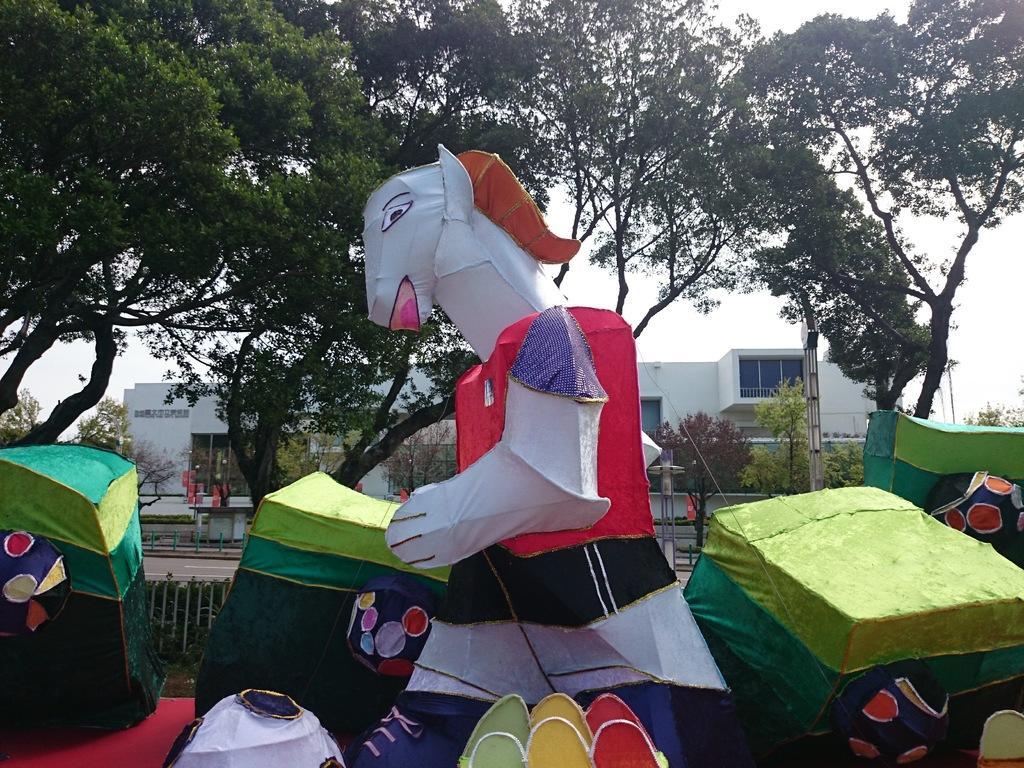In one or two sentences, can you explain what this image depicts? In this image I can see tents and a huge toy costume. There are trees and a building at the back. 